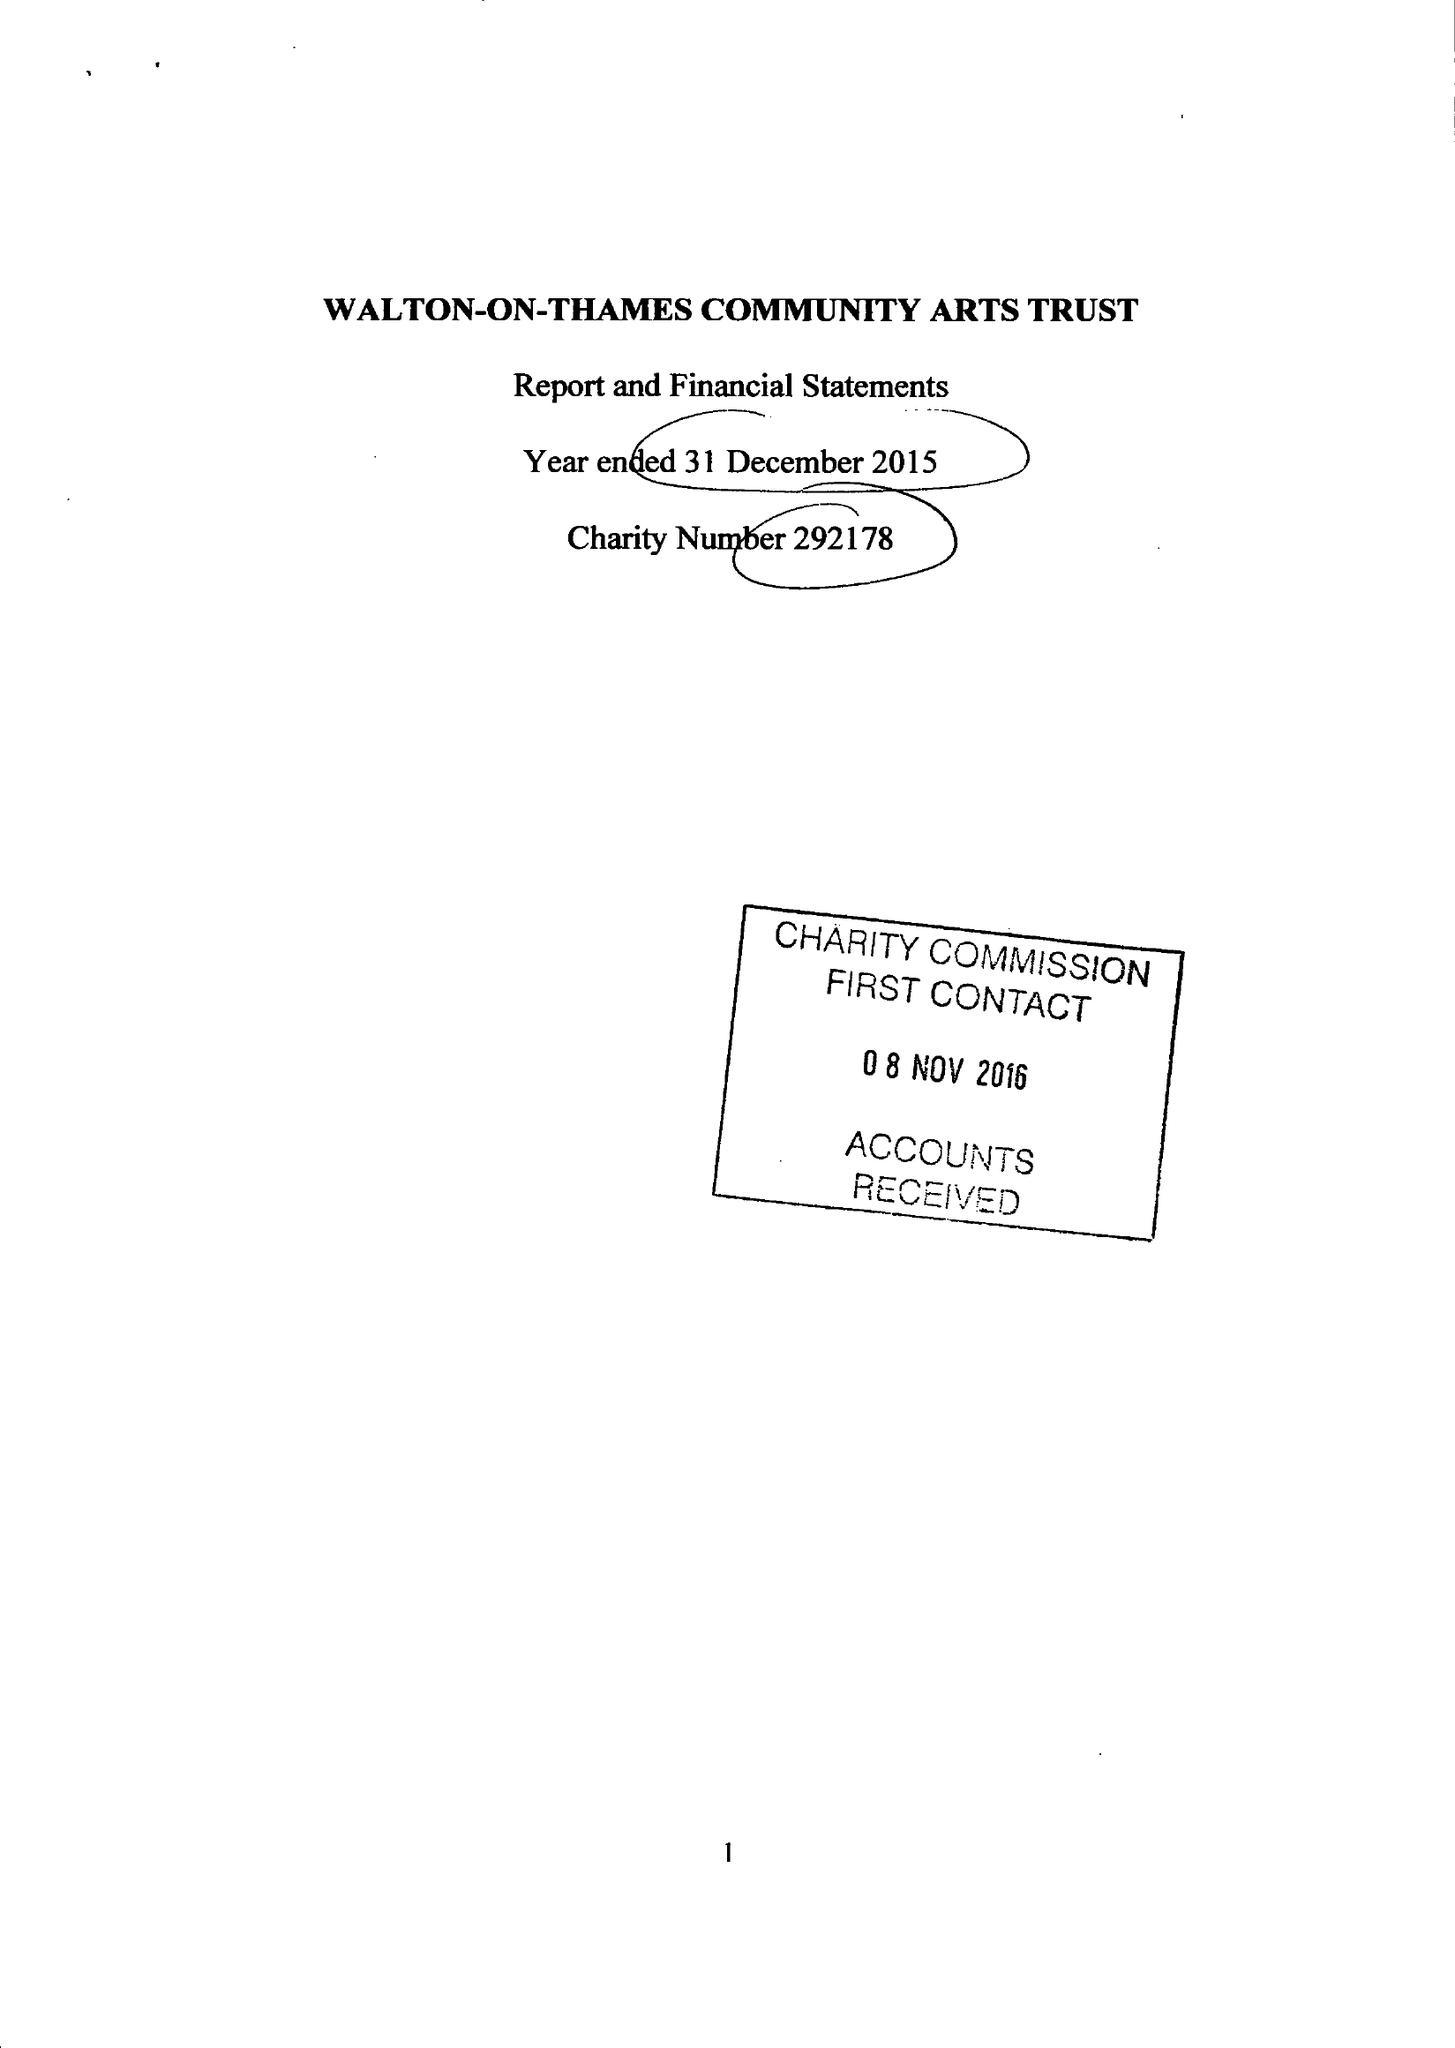What is the value for the spending_annually_in_british_pounds?
Answer the question using a single word or phrase. 33106.00 